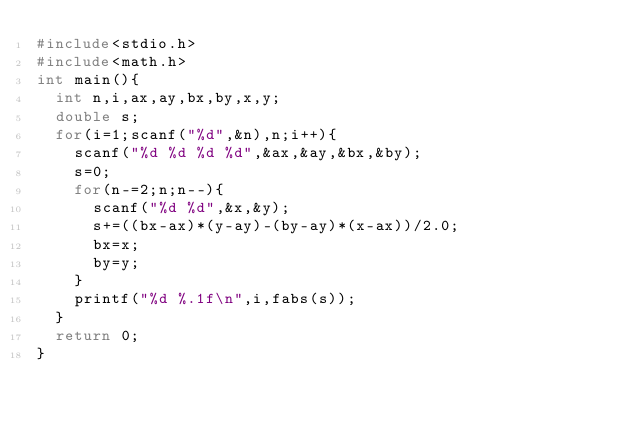Convert code to text. <code><loc_0><loc_0><loc_500><loc_500><_C_>#include<stdio.h>
#include<math.h>
int main(){
  int n,i,ax,ay,bx,by,x,y;
  double s;
  for(i=1;scanf("%d",&n),n;i++){
    scanf("%d %d %d %d",&ax,&ay,&bx,&by);
    s=0;
    for(n-=2;n;n--){
      scanf("%d %d",&x,&y);
      s+=((bx-ax)*(y-ay)-(by-ay)*(x-ax))/2.0;
      bx=x;
      by=y;
    }
    printf("%d %.1f\n",i,fabs(s));
  }
  return 0;
}</code> 